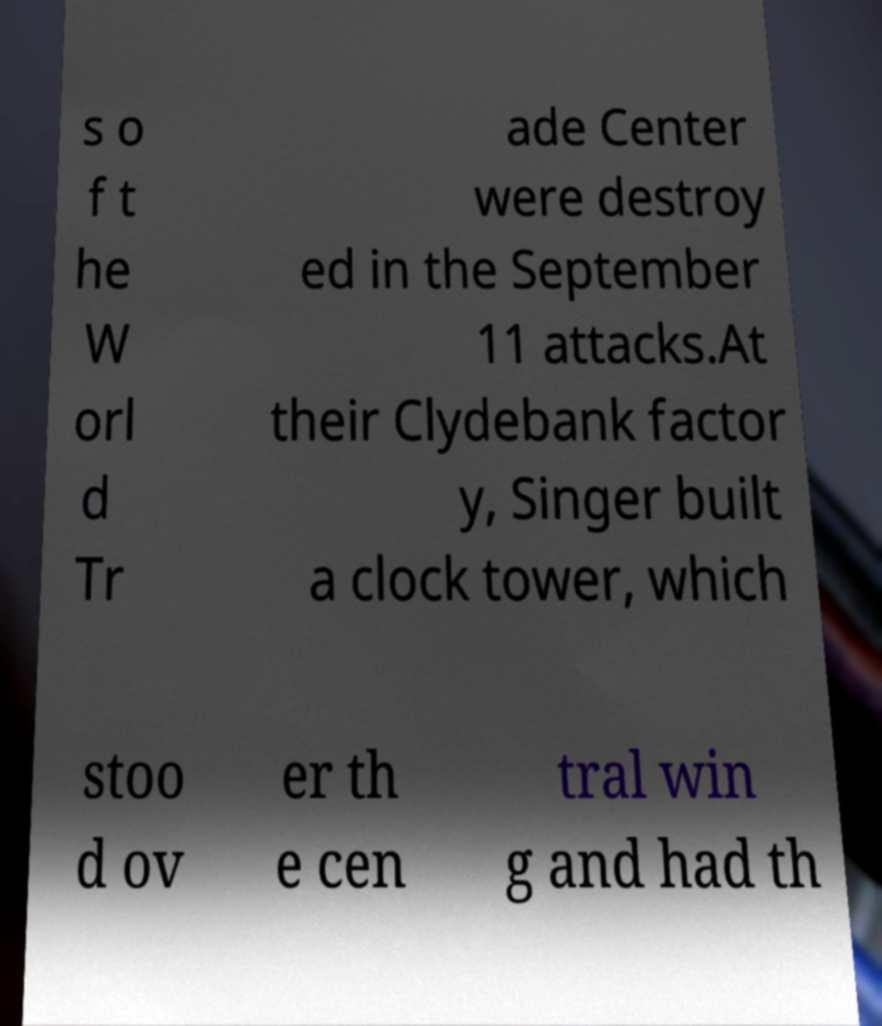Can you read and provide the text displayed in the image?This photo seems to have some interesting text. Can you extract and type it out for me? s o f t he W orl d Tr ade Center were destroy ed in the September 11 attacks.At their Clydebank factor y, Singer built a clock tower, which stoo d ov er th e cen tral win g and had th 